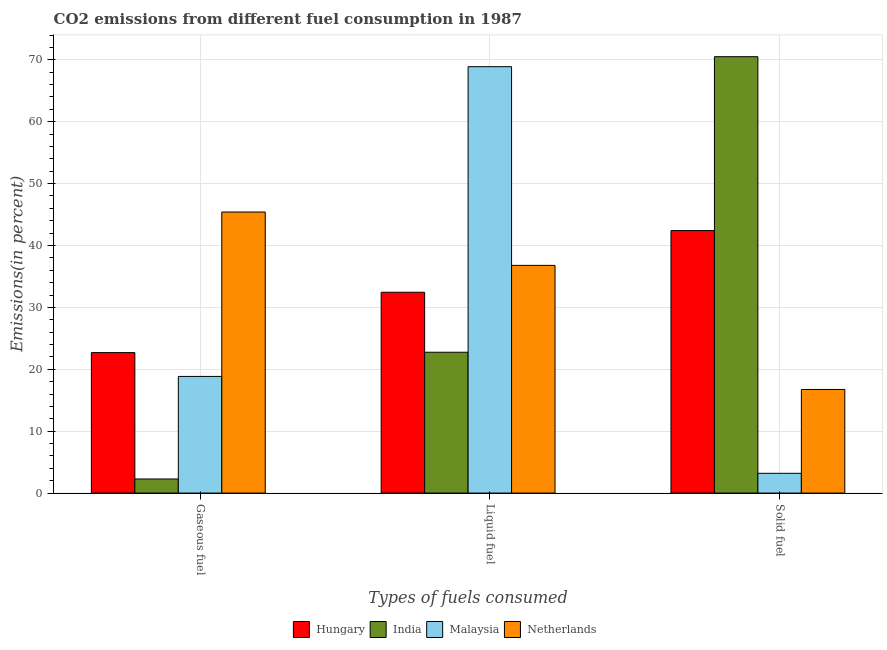How many different coloured bars are there?
Your response must be concise. 4. How many groups of bars are there?
Your answer should be very brief. 3. Are the number of bars per tick equal to the number of legend labels?
Ensure brevity in your answer.  Yes. Are the number of bars on each tick of the X-axis equal?
Your answer should be very brief. Yes. How many bars are there on the 1st tick from the right?
Offer a terse response. 4. What is the label of the 2nd group of bars from the left?
Offer a terse response. Liquid fuel. What is the percentage of solid fuel emission in Netherlands?
Keep it short and to the point. 16.74. Across all countries, what is the maximum percentage of solid fuel emission?
Ensure brevity in your answer.  70.5. Across all countries, what is the minimum percentage of solid fuel emission?
Provide a short and direct response. 3.19. In which country was the percentage of solid fuel emission maximum?
Offer a terse response. India. In which country was the percentage of solid fuel emission minimum?
Your response must be concise. Malaysia. What is the total percentage of solid fuel emission in the graph?
Provide a short and direct response. 132.84. What is the difference between the percentage of liquid fuel emission in Hungary and that in Netherlands?
Your answer should be compact. -4.34. What is the difference between the percentage of solid fuel emission in Malaysia and the percentage of gaseous fuel emission in India?
Make the answer very short. 0.92. What is the average percentage of liquid fuel emission per country?
Make the answer very short. 40.22. What is the difference between the percentage of liquid fuel emission and percentage of gaseous fuel emission in Hungary?
Make the answer very short. 9.75. What is the ratio of the percentage of solid fuel emission in Netherlands to that in Malaysia?
Your response must be concise. 5.24. What is the difference between the highest and the second highest percentage of gaseous fuel emission?
Offer a terse response. 22.71. What is the difference between the highest and the lowest percentage of gaseous fuel emission?
Ensure brevity in your answer.  43.13. Is the sum of the percentage of gaseous fuel emission in India and Malaysia greater than the maximum percentage of solid fuel emission across all countries?
Give a very brief answer. No. What does the 3rd bar from the left in Solid fuel represents?
Provide a succinct answer. Malaysia. What does the 3rd bar from the right in Gaseous fuel represents?
Your response must be concise. India. Does the graph contain grids?
Your answer should be very brief. Yes. What is the title of the graph?
Provide a succinct answer. CO2 emissions from different fuel consumption in 1987. What is the label or title of the X-axis?
Provide a short and direct response. Types of fuels consumed. What is the label or title of the Y-axis?
Make the answer very short. Emissions(in percent). What is the Emissions(in percent) in Hungary in Gaseous fuel?
Your answer should be very brief. 22.7. What is the Emissions(in percent) of India in Gaseous fuel?
Provide a succinct answer. 2.28. What is the Emissions(in percent) of Malaysia in Gaseous fuel?
Your response must be concise. 18.85. What is the Emissions(in percent) in Netherlands in Gaseous fuel?
Provide a short and direct response. 45.41. What is the Emissions(in percent) in Hungary in Liquid fuel?
Offer a very short reply. 32.45. What is the Emissions(in percent) of India in Liquid fuel?
Provide a short and direct response. 22.75. What is the Emissions(in percent) of Malaysia in Liquid fuel?
Ensure brevity in your answer.  68.89. What is the Emissions(in percent) of Netherlands in Liquid fuel?
Keep it short and to the point. 36.79. What is the Emissions(in percent) of Hungary in Solid fuel?
Offer a terse response. 42.41. What is the Emissions(in percent) in India in Solid fuel?
Your response must be concise. 70.5. What is the Emissions(in percent) of Malaysia in Solid fuel?
Keep it short and to the point. 3.19. What is the Emissions(in percent) of Netherlands in Solid fuel?
Give a very brief answer. 16.74. Across all Types of fuels consumed, what is the maximum Emissions(in percent) of Hungary?
Offer a terse response. 42.41. Across all Types of fuels consumed, what is the maximum Emissions(in percent) in India?
Provide a short and direct response. 70.5. Across all Types of fuels consumed, what is the maximum Emissions(in percent) in Malaysia?
Provide a succinct answer. 68.89. Across all Types of fuels consumed, what is the maximum Emissions(in percent) in Netherlands?
Keep it short and to the point. 45.41. Across all Types of fuels consumed, what is the minimum Emissions(in percent) in Hungary?
Your answer should be very brief. 22.7. Across all Types of fuels consumed, what is the minimum Emissions(in percent) in India?
Your answer should be very brief. 2.28. Across all Types of fuels consumed, what is the minimum Emissions(in percent) of Malaysia?
Give a very brief answer. 3.19. Across all Types of fuels consumed, what is the minimum Emissions(in percent) of Netherlands?
Keep it short and to the point. 16.74. What is the total Emissions(in percent) in Hungary in the graph?
Provide a succinct answer. 97.55. What is the total Emissions(in percent) in India in the graph?
Keep it short and to the point. 95.54. What is the total Emissions(in percent) in Malaysia in the graph?
Your response must be concise. 90.93. What is the total Emissions(in percent) of Netherlands in the graph?
Make the answer very short. 98.94. What is the difference between the Emissions(in percent) in Hungary in Gaseous fuel and that in Liquid fuel?
Offer a very short reply. -9.75. What is the difference between the Emissions(in percent) in India in Gaseous fuel and that in Liquid fuel?
Provide a succinct answer. -20.48. What is the difference between the Emissions(in percent) of Malaysia in Gaseous fuel and that in Liquid fuel?
Your answer should be very brief. -50.05. What is the difference between the Emissions(in percent) of Netherlands in Gaseous fuel and that in Liquid fuel?
Provide a short and direct response. 8.62. What is the difference between the Emissions(in percent) of Hungary in Gaseous fuel and that in Solid fuel?
Offer a terse response. -19.71. What is the difference between the Emissions(in percent) in India in Gaseous fuel and that in Solid fuel?
Ensure brevity in your answer.  -68.23. What is the difference between the Emissions(in percent) of Malaysia in Gaseous fuel and that in Solid fuel?
Your response must be concise. 15.65. What is the difference between the Emissions(in percent) of Netherlands in Gaseous fuel and that in Solid fuel?
Keep it short and to the point. 28.67. What is the difference between the Emissions(in percent) of Hungary in Liquid fuel and that in Solid fuel?
Offer a very short reply. -9.96. What is the difference between the Emissions(in percent) of India in Liquid fuel and that in Solid fuel?
Provide a short and direct response. -47.75. What is the difference between the Emissions(in percent) in Malaysia in Liquid fuel and that in Solid fuel?
Provide a succinct answer. 65.7. What is the difference between the Emissions(in percent) of Netherlands in Liquid fuel and that in Solid fuel?
Your response must be concise. 20.05. What is the difference between the Emissions(in percent) of Hungary in Gaseous fuel and the Emissions(in percent) of India in Liquid fuel?
Keep it short and to the point. -0.06. What is the difference between the Emissions(in percent) of Hungary in Gaseous fuel and the Emissions(in percent) of Malaysia in Liquid fuel?
Your answer should be very brief. -46.2. What is the difference between the Emissions(in percent) in Hungary in Gaseous fuel and the Emissions(in percent) in Netherlands in Liquid fuel?
Your answer should be compact. -14.09. What is the difference between the Emissions(in percent) of India in Gaseous fuel and the Emissions(in percent) of Malaysia in Liquid fuel?
Make the answer very short. -66.61. What is the difference between the Emissions(in percent) of India in Gaseous fuel and the Emissions(in percent) of Netherlands in Liquid fuel?
Provide a short and direct response. -34.51. What is the difference between the Emissions(in percent) in Malaysia in Gaseous fuel and the Emissions(in percent) in Netherlands in Liquid fuel?
Your answer should be very brief. -17.94. What is the difference between the Emissions(in percent) of Hungary in Gaseous fuel and the Emissions(in percent) of India in Solid fuel?
Offer a terse response. -47.81. What is the difference between the Emissions(in percent) in Hungary in Gaseous fuel and the Emissions(in percent) in Malaysia in Solid fuel?
Provide a short and direct response. 19.5. What is the difference between the Emissions(in percent) in Hungary in Gaseous fuel and the Emissions(in percent) in Netherlands in Solid fuel?
Your answer should be compact. 5.96. What is the difference between the Emissions(in percent) of India in Gaseous fuel and the Emissions(in percent) of Malaysia in Solid fuel?
Make the answer very short. -0.92. What is the difference between the Emissions(in percent) in India in Gaseous fuel and the Emissions(in percent) in Netherlands in Solid fuel?
Your response must be concise. -14.46. What is the difference between the Emissions(in percent) of Malaysia in Gaseous fuel and the Emissions(in percent) of Netherlands in Solid fuel?
Offer a very short reply. 2.11. What is the difference between the Emissions(in percent) in Hungary in Liquid fuel and the Emissions(in percent) in India in Solid fuel?
Provide a succinct answer. -38.06. What is the difference between the Emissions(in percent) in Hungary in Liquid fuel and the Emissions(in percent) in Malaysia in Solid fuel?
Your answer should be very brief. 29.25. What is the difference between the Emissions(in percent) of Hungary in Liquid fuel and the Emissions(in percent) of Netherlands in Solid fuel?
Ensure brevity in your answer.  15.71. What is the difference between the Emissions(in percent) in India in Liquid fuel and the Emissions(in percent) in Malaysia in Solid fuel?
Give a very brief answer. 19.56. What is the difference between the Emissions(in percent) of India in Liquid fuel and the Emissions(in percent) of Netherlands in Solid fuel?
Keep it short and to the point. 6.02. What is the difference between the Emissions(in percent) in Malaysia in Liquid fuel and the Emissions(in percent) in Netherlands in Solid fuel?
Offer a terse response. 52.15. What is the average Emissions(in percent) of Hungary per Types of fuels consumed?
Your answer should be compact. 32.52. What is the average Emissions(in percent) of India per Types of fuels consumed?
Your response must be concise. 31.85. What is the average Emissions(in percent) in Malaysia per Types of fuels consumed?
Offer a very short reply. 30.31. What is the average Emissions(in percent) of Netherlands per Types of fuels consumed?
Your answer should be very brief. 32.98. What is the difference between the Emissions(in percent) of Hungary and Emissions(in percent) of India in Gaseous fuel?
Make the answer very short. 20.42. What is the difference between the Emissions(in percent) in Hungary and Emissions(in percent) in Malaysia in Gaseous fuel?
Ensure brevity in your answer.  3.85. What is the difference between the Emissions(in percent) in Hungary and Emissions(in percent) in Netherlands in Gaseous fuel?
Your answer should be very brief. -22.71. What is the difference between the Emissions(in percent) in India and Emissions(in percent) in Malaysia in Gaseous fuel?
Your answer should be compact. -16.57. What is the difference between the Emissions(in percent) in India and Emissions(in percent) in Netherlands in Gaseous fuel?
Your answer should be very brief. -43.13. What is the difference between the Emissions(in percent) in Malaysia and Emissions(in percent) in Netherlands in Gaseous fuel?
Offer a very short reply. -26.56. What is the difference between the Emissions(in percent) of Hungary and Emissions(in percent) of India in Liquid fuel?
Your answer should be very brief. 9.69. What is the difference between the Emissions(in percent) of Hungary and Emissions(in percent) of Malaysia in Liquid fuel?
Make the answer very short. -36.45. What is the difference between the Emissions(in percent) of Hungary and Emissions(in percent) of Netherlands in Liquid fuel?
Give a very brief answer. -4.34. What is the difference between the Emissions(in percent) of India and Emissions(in percent) of Malaysia in Liquid fuel?
Your answer should be very brief. -46.14. What is the difference between the Emissions(in percent) in India and Emissions(in percent) in Netherlands in Liquid fuel?
Give a very brief answer. -14.03. What is the difference between the Emissions(in percent) of Malaysia and Emissions(in percent) of Netherlands in Liquid fuel?
Your answer should be compact. 32.1. What is the difference between the Emissions(in percent) of Hungary and Emissions(in percent) of India in Solid fuel?
Your response must be concise. -28.1. What is the difference between the Emissions(in percent) of Hungary and Emissions(in percent) of Malaysia in Solid fuel?
Your answer should be very brief. 39.22. What is the difference between the Emissions(in percent) of Hungary and Emissions(in percent) of Netherlands in Solid fuel?
Provide a short and direct response. 25.67. What is the difference between the Emissions(in percent) of India and Emissions(in percent) of Malaysia in Solid fuel?
Make the answer very short. 67.31. What is the difference between the Emissions(in percent) of India and Emissions(in percent) of Netherlands in Solid fuel?
Your response must be concise. 53.77. What is the difference between the Emissions(in percent) in Malaysia and Emissions(in percent) in Netherlands in Solid fuel?
Your answer should be very brief. -13.54. What is the ratio of the Emissions(in percent) of Hungary in Gaseous fuel to that in Liquid fuel?
Keep it short and to the point. 0.7. What is the ratio of the Emissions(in percent) of India in Gaseous fuel to that in Liquid fuel?
Offer a very short reply. 0.1. What is the ratio of the Emissions(in percent) in Malaysia in Gaseous fuel to that in Liquid fuel?
Give a very brief answer. 0.27. What is the ratio of the Emissions(in percent) of Netherlands in Gaseous fuel to that in Liquid fuel?
Provide a short and direct response. 1.23. What is the ratio of the Emissions(in percent) in Hungary in Gaseous fuel to that in Solid fuel?
Your answer should be compact. 0.54. What is the ratio of the Emissions(in percent) in India in Gaseous fuel to that in Solid fuel?
Your response must be concise. 0.03. What is the ratio of the Emissions(in percent) in Malaysia in Gaseous fuel to that in Solid fuel?
Provide a succinct answer. 5.9. What is the ratio of the Emissions(in percent) in Netherlands in Gaseous fuel to that in Solid fuel?
Keep it short and to the point. 2.71. What is the ratio of the Emissions(in percent) in Hungary in Liquid fuel to that in Solid fuel?
Offer a terse response. 0.77. What is the ratio of the Emissions(in percent) of India in Liquid fuel to that in Solid fuel?
Keep it short and to the point. 0.32. What is the ratio of the Emissions(in percent) in Malaysia in Liquid fuel to that in Solid fuel?
Offer a very short reply. 21.57. What is the ratio of the Emissions(in percent) of Netherlands in Liquid fuel to that in Solid fuel?
Your response must be concise. 2.2. What is the difference between the highest and the second highest Emissions(in percent) in Hungary?
Your answer should be very brief. 9.96. What is the difference between the highest and the second highest Emissions(in percent) of India?
Provide a succinct answer. 47.75. What is the difference between the highest and the second highest Emissions(in percent) in Malaysia?
Ensure brevity in your answer.  50.05. What is the difference between the highest and the second highest Emissions(in percent) of Netherlands?
Offer a very short reply. 8.62. What is the difference between the highest and the lowest Emissions(in percent) in Hungary?
Offer a very short reply. 19.71. What is the difference between the highest and the lowest Emissions(in percent) of India?
Your answer should be compact. 68.23. What is the difference between the highest and the lowest Emissions(in percent) of Malaysia?
Provide a succinct answer. 65.7. What is the difference between the highest and the lowest Emissions(in percent) of Netherlands?
Keep it short and to the point. 28.67. 